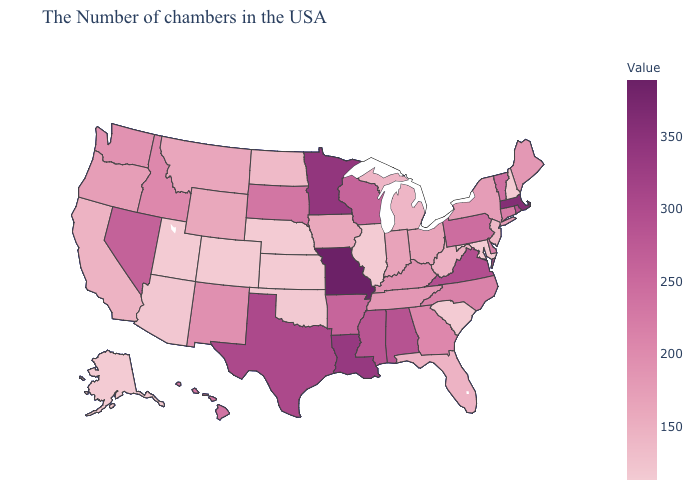Does South Dakota have the lowest value in the USA?
Quick response, please. No. Does Massachusetts have the highest value in the Northeast?
Short answer required. Yes. Which states have the highest value in the USA?
Be succinct. Missouri. 